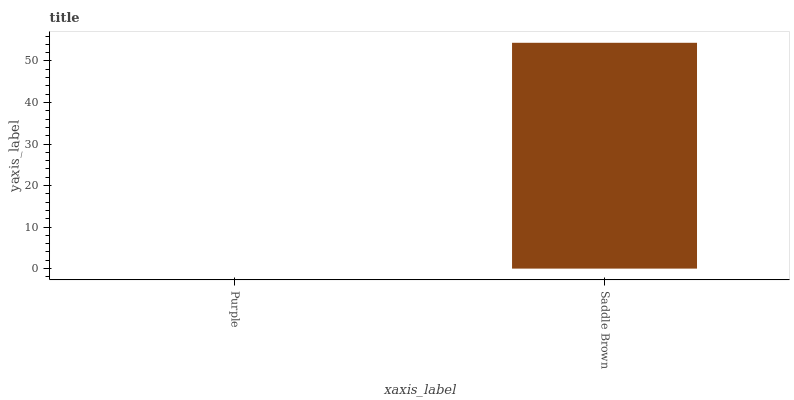Is Purple the minimum?
Answer yes or no. Yes. Is Saddle Brown the maximum?
Answer yes or no. Yes. Is Saddle Brown the minimum?
Answer yes or no. No. Is Saddle Brown greater than Purple?
Answer yes or no. Yes. Is Purple less than Saddle Brown?
Answer yes or no. Yes. Is Purple greater than Saddle Brown?
Answer yes or no. No. Is Saddle Brown less than Purple?
Answer yes or no. No. Is Saddle Brown the high median?
Answer yes or no. Yes. Is Purple the low median?
Answer yes or no. Yes. Is Purple the high median?
Answer yes or no. No. Is Saddle Brown the low median?
Answer yes or no. No. 